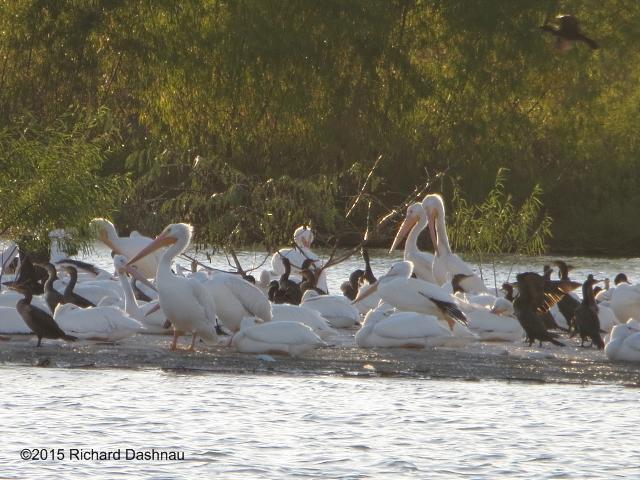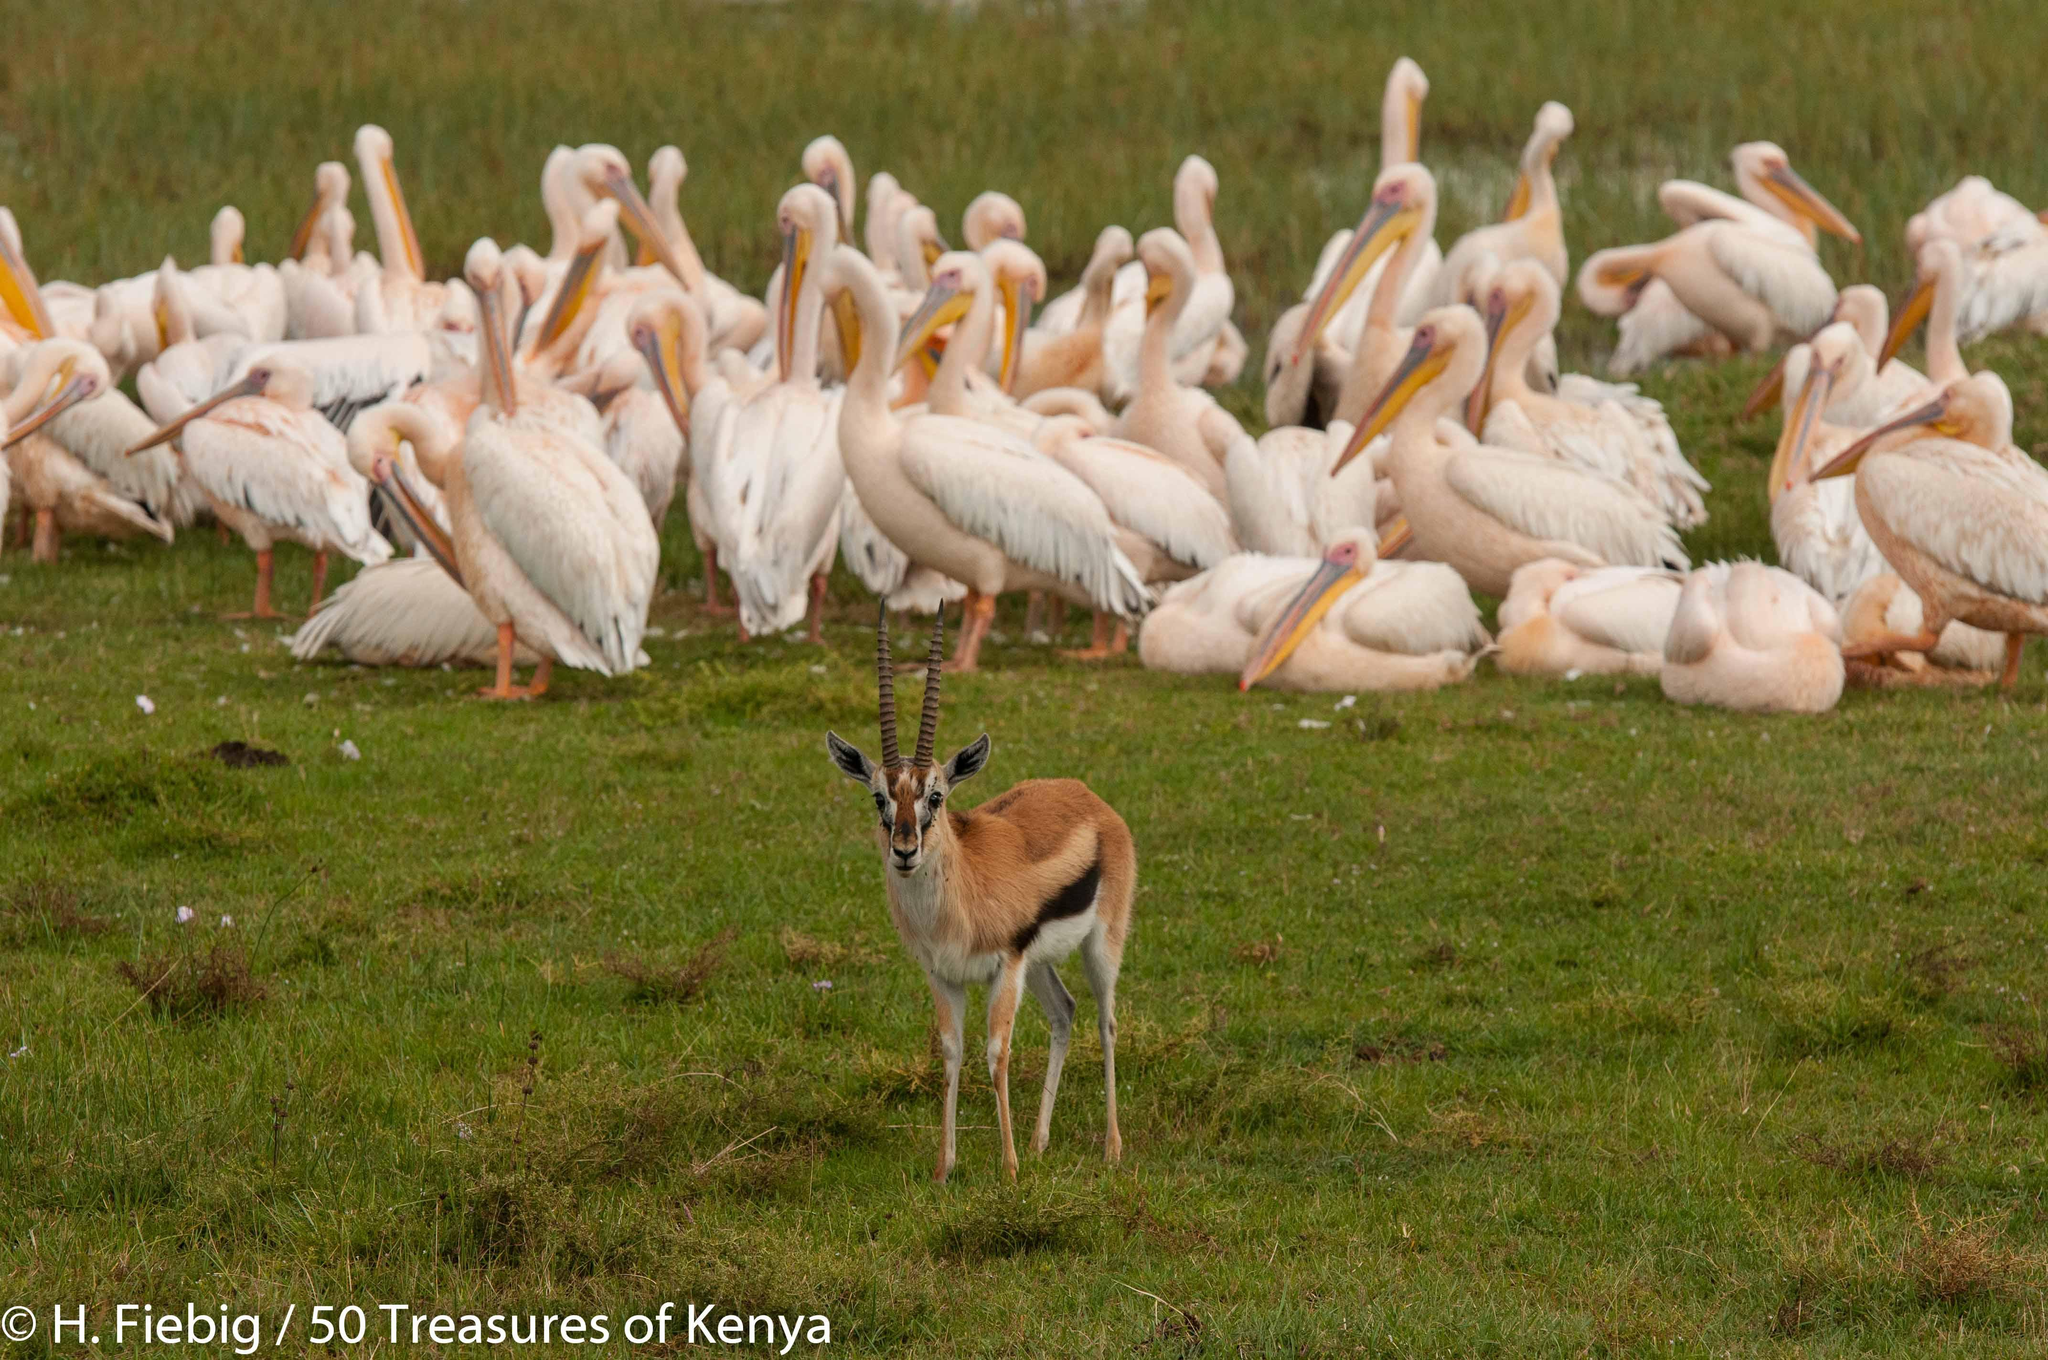The first image is the image on the left, the second image is the image on the right. Examine the images to the left and right. Is the description "In at least one photo, there are fewer than 5 birds." accurate? Answer yes or no. No. The first image is the image on the left, the second image is the image on the right. Analyze the images presented: Is the assertion "There  are at least 20 pelicans with white feathers and orange beak sitting together with no water in sight." valid? Answer yes or no. Yes. 